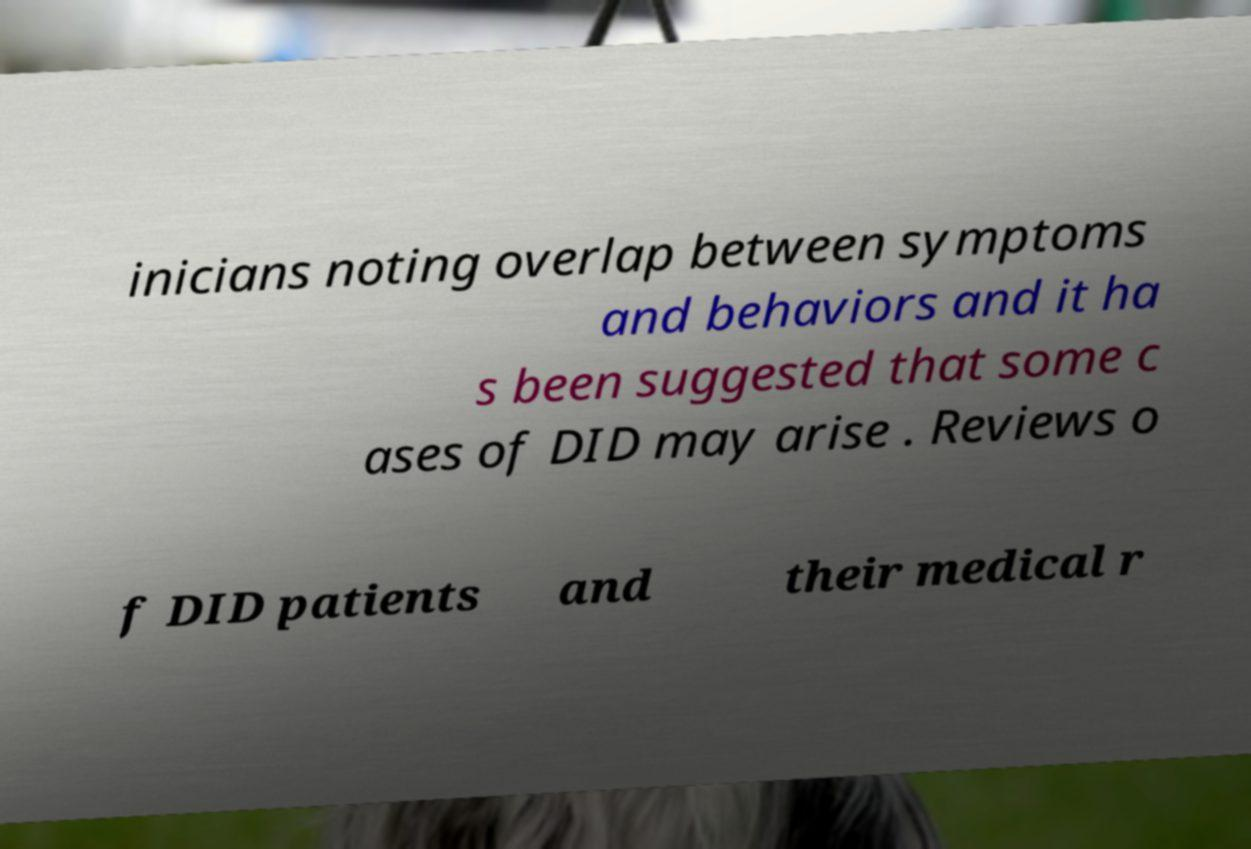Can you read and provide the text displayed in the image?This photo seems to have some interesting text. Can you extract and type it out for me? inicians noting overlap between symptoms and behaviors and it ha s been suggested that some c ases of DID may arise . Reviews o f DID patients and their medical r 